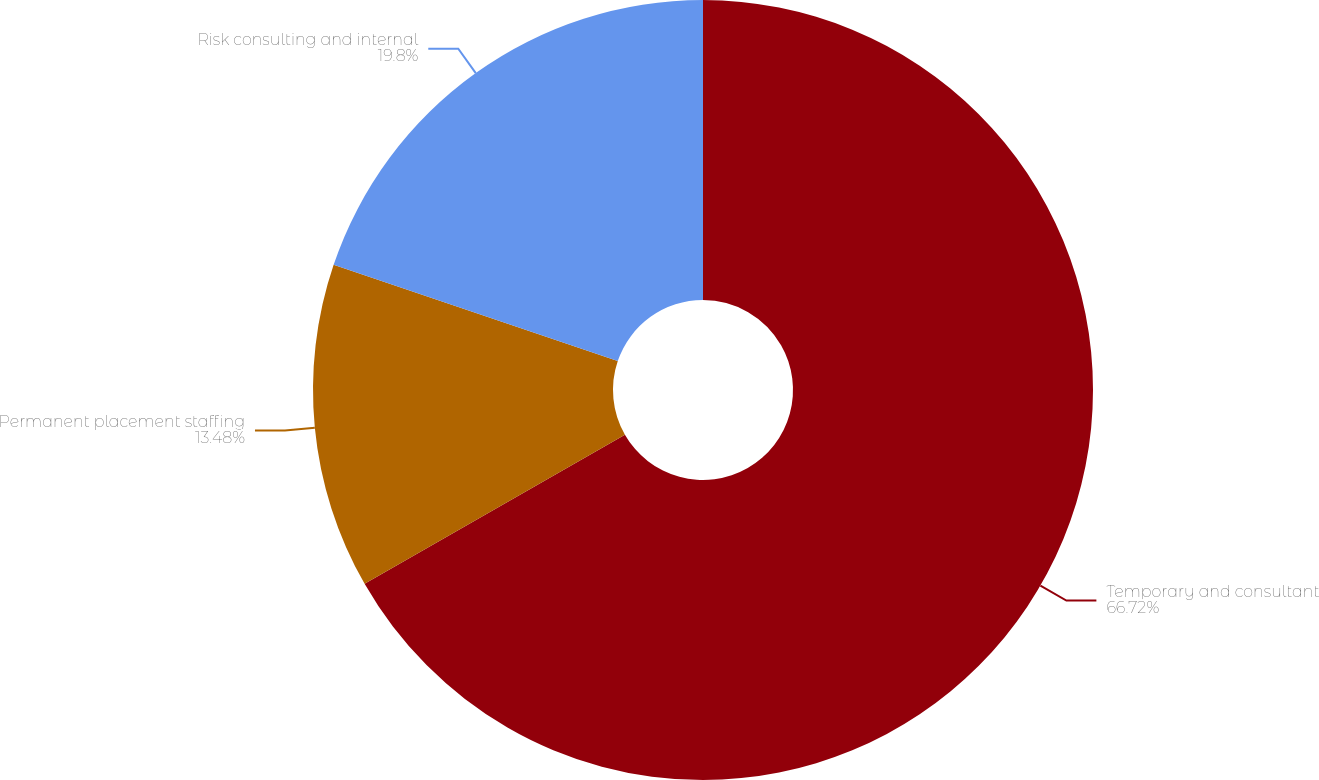Convert chart to OTSL. <chart><loc_0><loc_0><loc_500><loc_500><pie_chart><fcel>Temporary and consultant<fcel>Permanent placement staffing<fcel>Risk consulting and internal<nl><fcel>66.72%<fcel>13.48%<fcel>19.8%<nl></chart> 